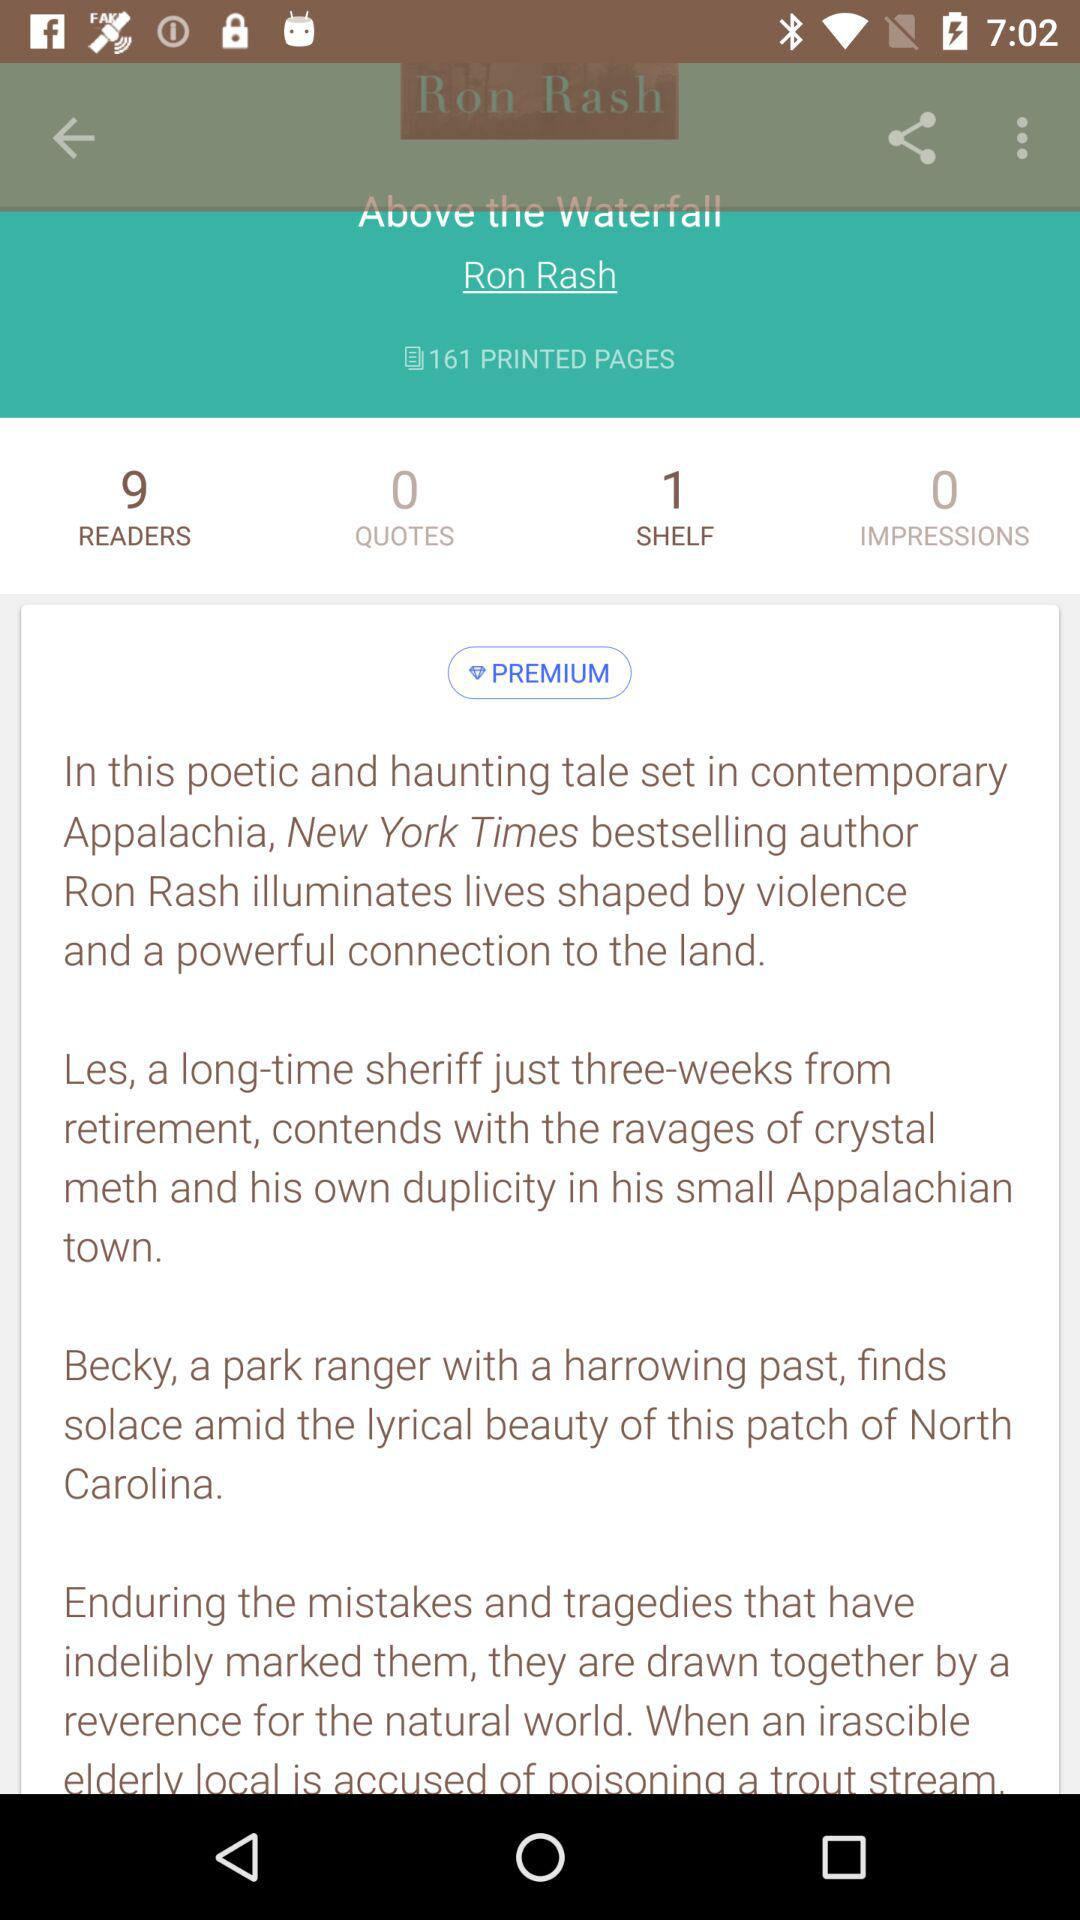What is the count for the shelf? The count for the shelf is 1. 